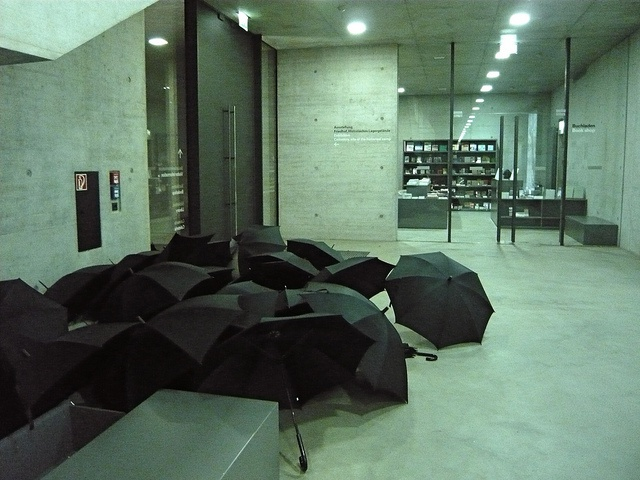Describe the objects in this image and their specific colors. I can see umbrella in lightblue, black, and gray tones, umbrella in lightblue, black, gray, and darkgreen tones, umbrella in lightblue, black, and darkgreen tones, umbrella in lightblue, black, teal, and darkgreen tones, and umbrella in lightblue, black, and teal tones in this image. 